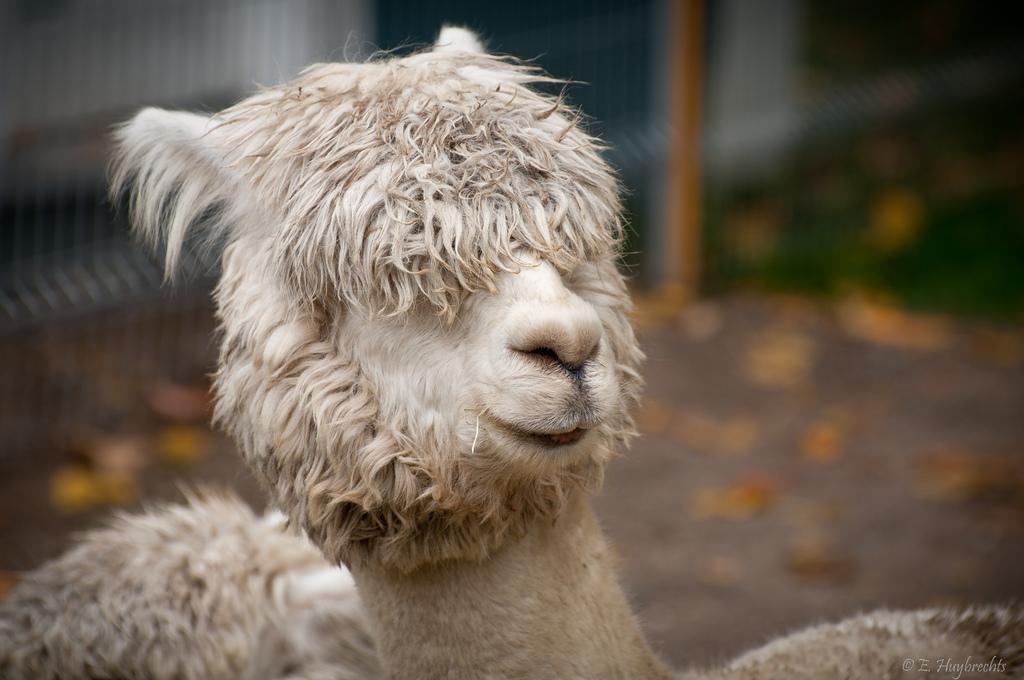In one or two sentences, can you explain what this image depicts? In this picture we can see two animals and in the background we can see fence, grass and it is blurry. 